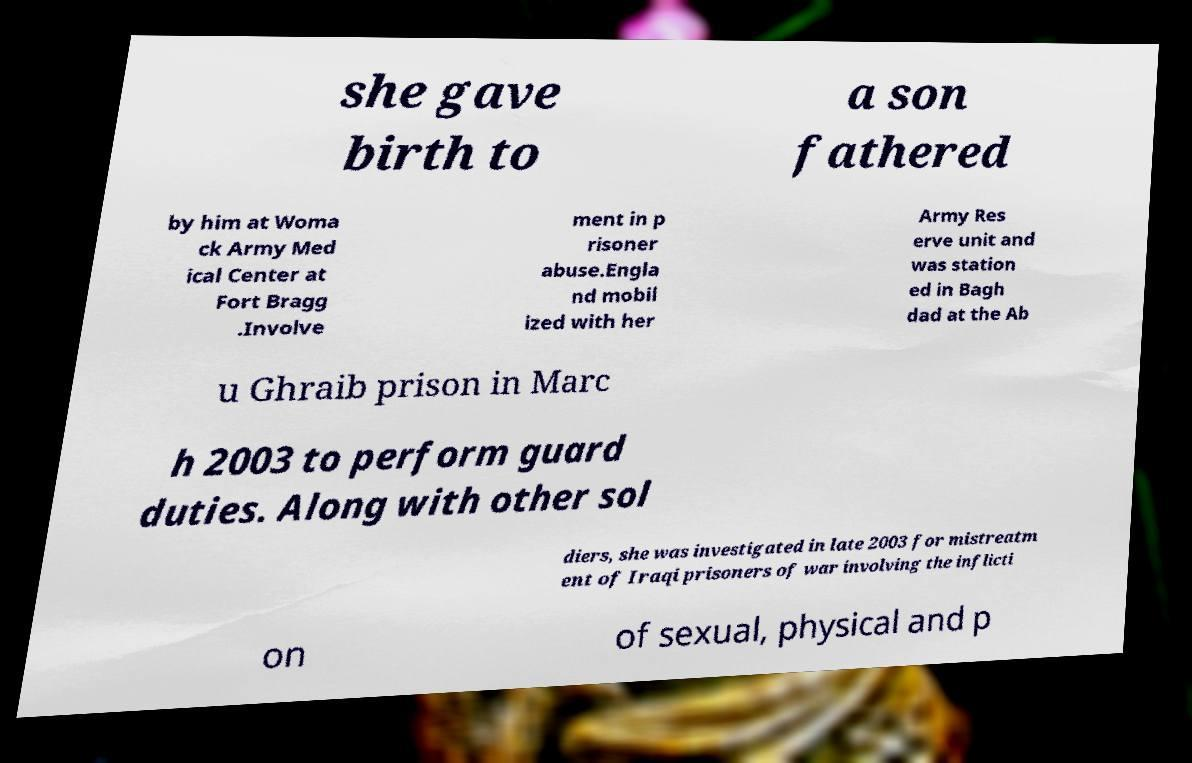Can you read and provide the text displayed in the image?This photo seems to have some interesting text. Can you extract and type it out for me? she gave birth to a son fathered by him at Woma ck Army Med ical Center at Fort Bragg .Involve ment in p risoner abuse.Engla nd mobil ized with her Army Res erve unit and was station ed in Bagh dad at the Ab u Ghraib prison in Marc h 2003 to perform guard duties. Along with other sol diers, she was investigated in late 2003 for mistreatm ent of Iraqi prisoners of war involving the inflicti on of sexual, physical and p 